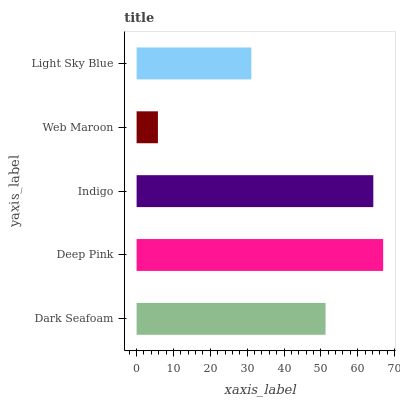Is Web Maroon the minimum?
Answer yes or no. Yes. Is Deep Pink the maximum?
Answer yes or no. Yes. Is Indigo the minimum?
Answer yes or no. No. Is Indigo the maximum?
Answer yes or no. No. Is Deep Pink greater than Indigo?
Answer yes or no. Yes. Is Indigo less than Deep Pink?
Answer yes or no. Yes. Is Indigo greater than Deep Pink?
Answer yes or no. No. Is Deep Pink less than Indigo?
Answer yes or no. No. Is Dark Seafoam the high median?
Answer yes or no. Yes. Is Dark Seafoam the low median?
Answer yes or no. Yes. Is Deep Pink the high median?
Answer yes or no. No. Is Light Sky Blue the low median?
Answer yes or no. No. 